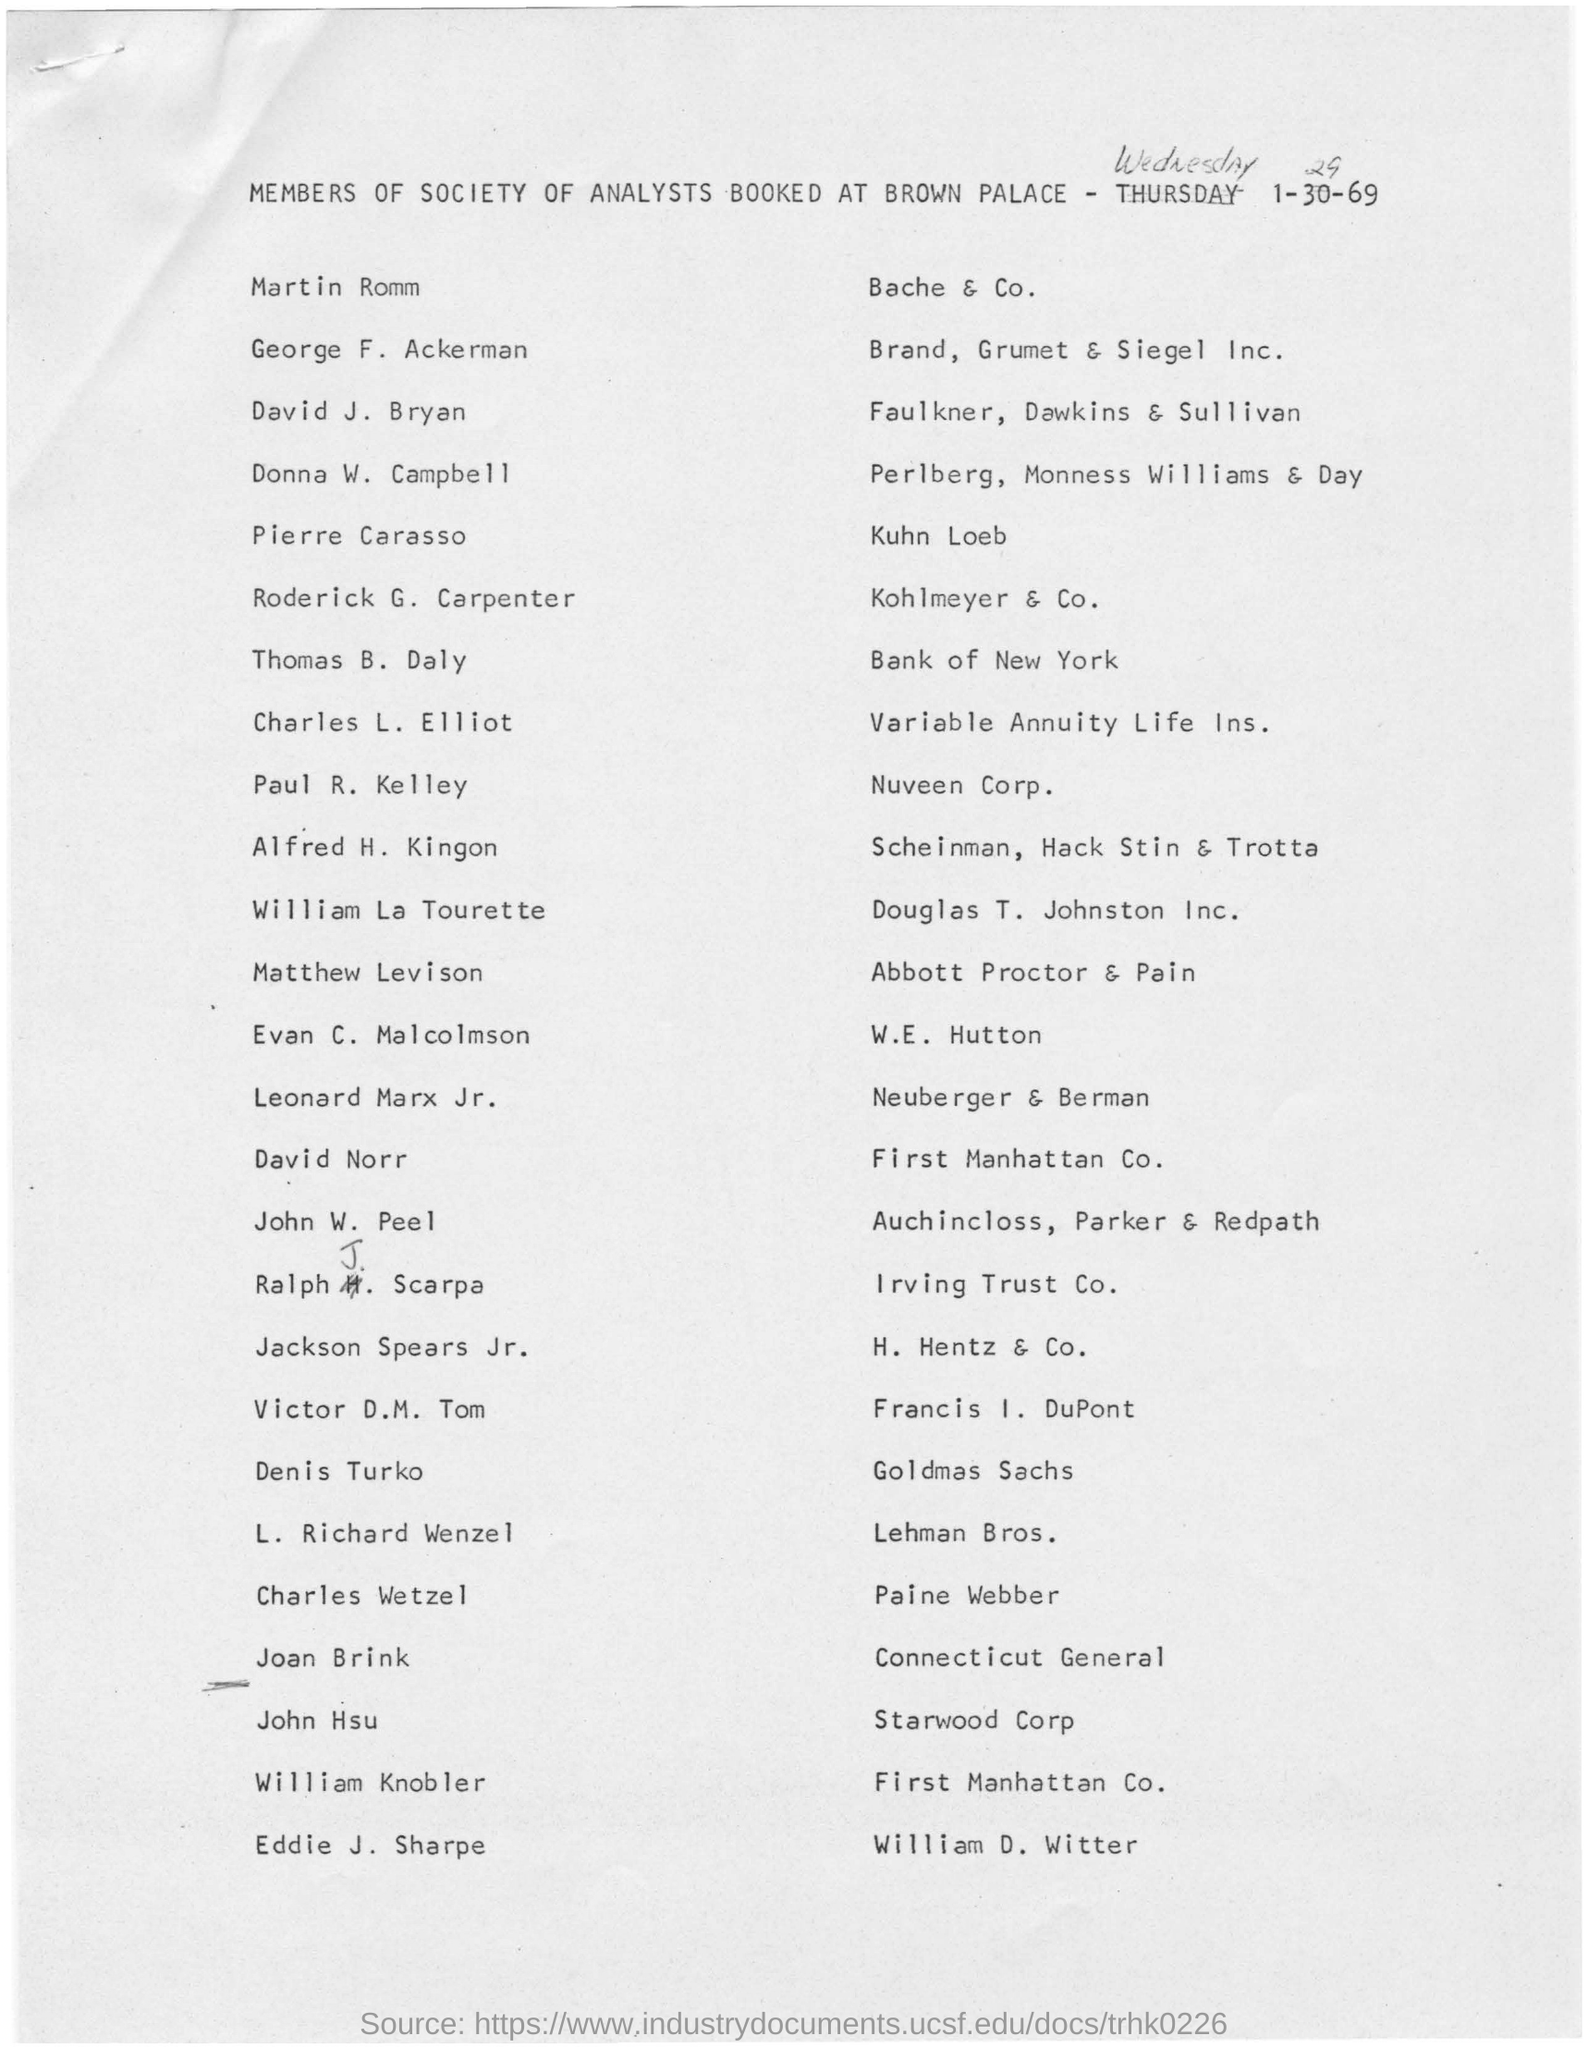Highlight a few significant elements in this photo. The members of the Society of Analysts at Brown Palace belong to a society. 